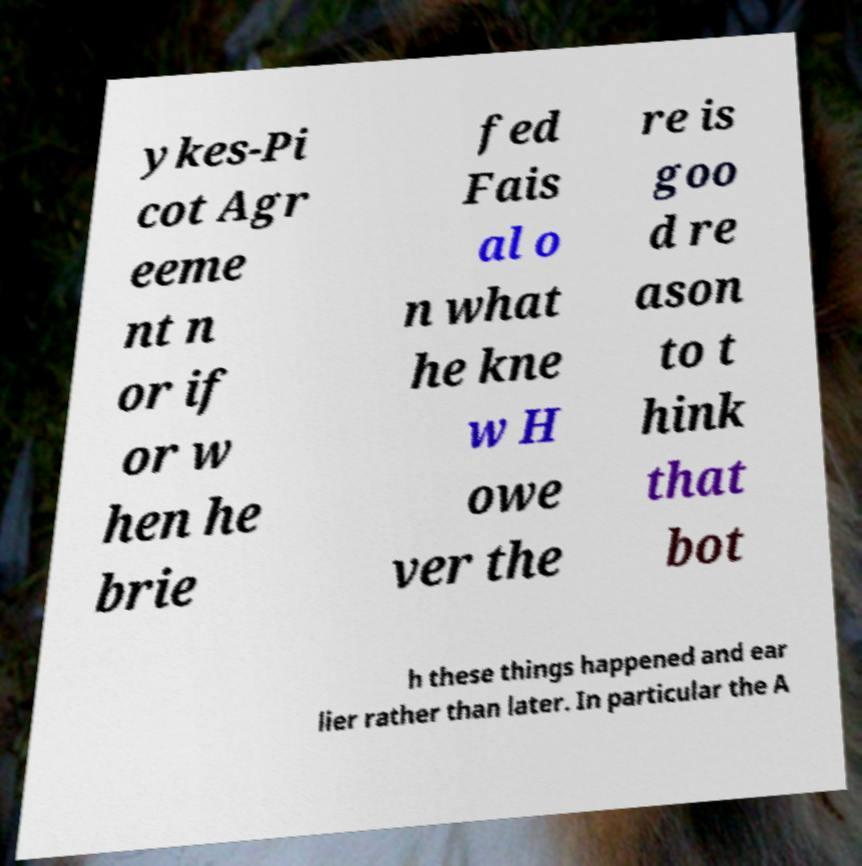Please identify and transcribe the text found in this image. ykes-Pi cot Agr eeme nt n or if or w hen he brie fed Fais al o n what he kne w H owe ver the re is goo d re ason to t hink that bot h these things happened and ear lier rather than later. In particular the A 